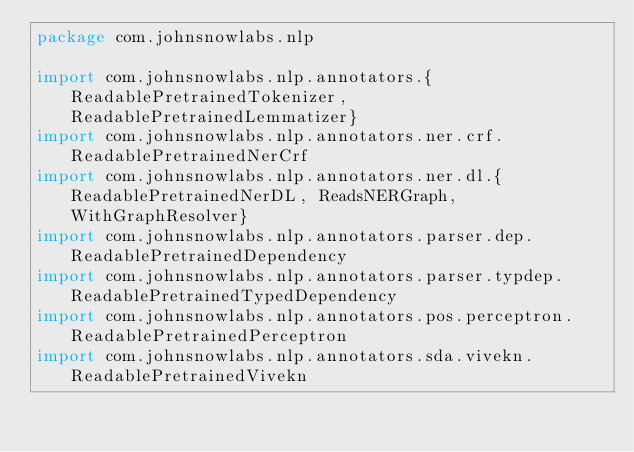Convert code to text. <code><loc_0><loc_0><loc_500><loc_500><_Scala_>package com.johnsnowlabs.nlp

import com.johnsnowlabs.nlp.annotators.{ReadablePretrainedTokenizer, ReadablePretrainedLemmatizer}
import com.johnsnowlabs.nlp.annotators.ner.crf.ReadablePretrainedNerCrf
import com.johnsnowlabs.nlp.annotators.ner.dl.{ReadablePretrainedNerDL, ReadsNERGraph, WithGraphResolver}
import com.johnsnowlabs.nlp.annotators.parser.dep.ReadablePretrainedDependency
import com.johnsnowlabs.nlp.annotators.parser.typdep.ReadablePretrainedTypedDependency
import com.johnsnowlabs.nlp.annotators.pos.perceptron.ReadablePretrainedPerceptron
import com.johnsnowlabs.nlp.annotators.sda.vivekn.ReadablePretrainedVivekn</code> 